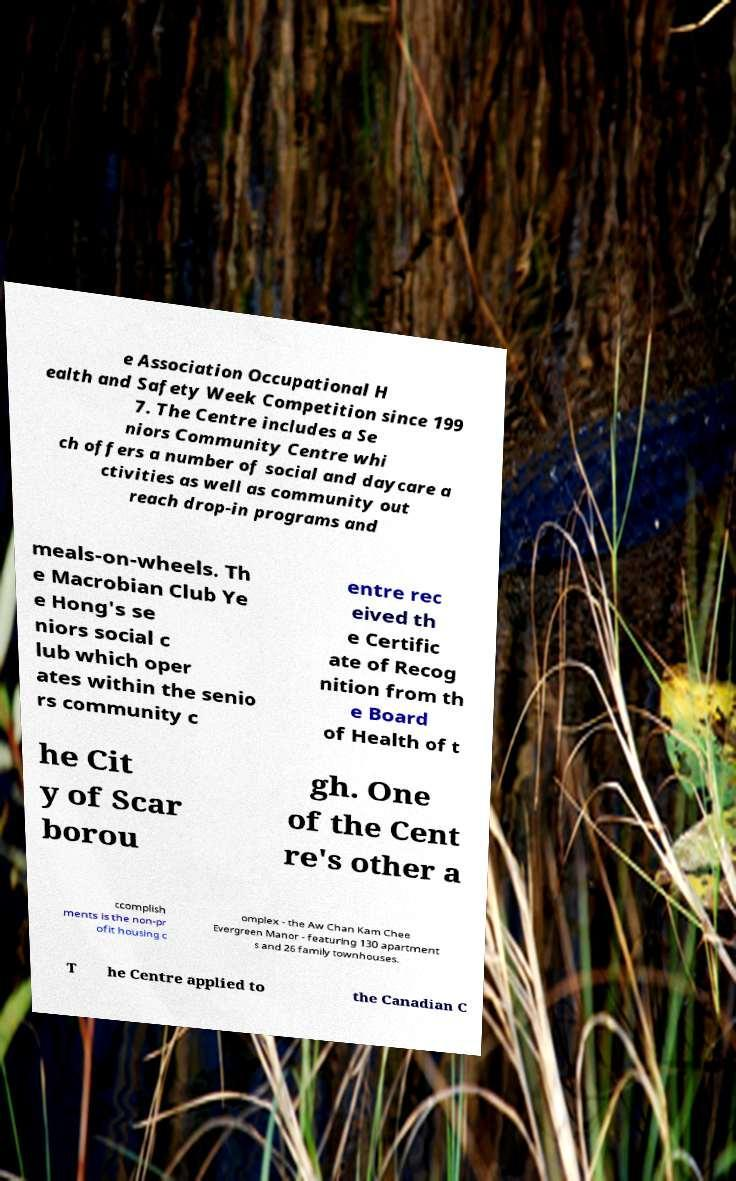Can you accurately transcribe the text from the provided image for me? e Association Occupational H ealth and Safety Week Competition since 199 7. The Centre includes a Se niors Community Centre whi ch offers a number of social and daycare a ctivities as well as community out reach drop-in programs and meals-on-wheels. Th e Macrobian Club Ye e Hong's se niors social c lub which oper ates within the senio rs community c entre rec eived th e Certific ate of Recog nition from th e Board of Health of t he Cit y of Scar borou gh. One of the Cent re's other a ccomplish ments is the non-pr ofit housing c omplex - the Aw Chan Kam Chee Evergreen Manor - featuring 130 apartment s and 26 family townhouses. T he Centre applied to the Canadian C 